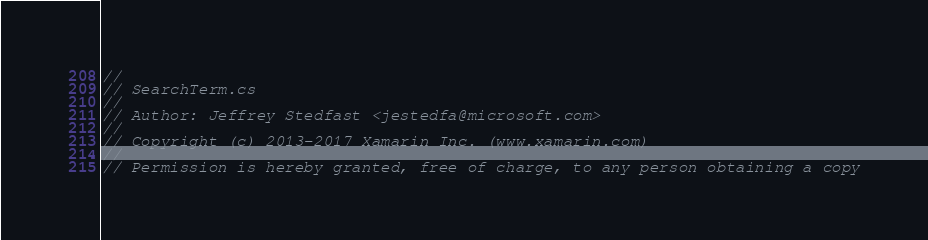<code> <loc_0><loc_0><loc_500><loc_500><_C#_>//
// SearchTerm.cs
//
// Author: Jeffrey Stedfast <jestedfa@microsoft.com>
//
// Copyright (c) 2013-2017 Xamarin Inc. (www.xamarin.com)
//
// Permission is hereby granted, free of charge, to any person obtaining a copy</code> 